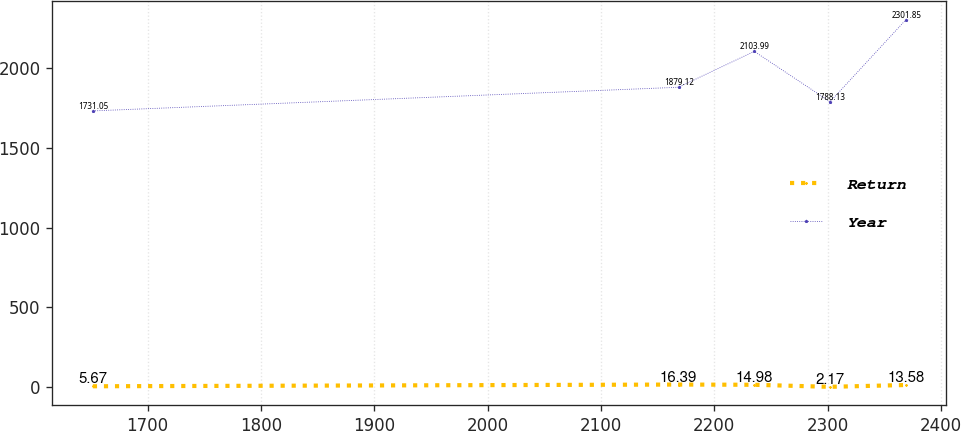Convert chart to OTSL. <chart><loc_0><loc_0><loc_500><loc_500><line_chart><ecel><fcel>Return<fcel>Year<nl><fcel>1651.72<fcel>5.67<fcel>1731.05<nl><fcel>2168.4<fcel>16.39<fcel>1879.12<nl><fcel>2235.25<fcel>14.98<fcel>2103.99<nl><fcel>2302.1<fcel>2.17<fcel>1788.13<nl><fcel>2368.95<fcel>13.58<fcel>2301.85<nl></chart> 